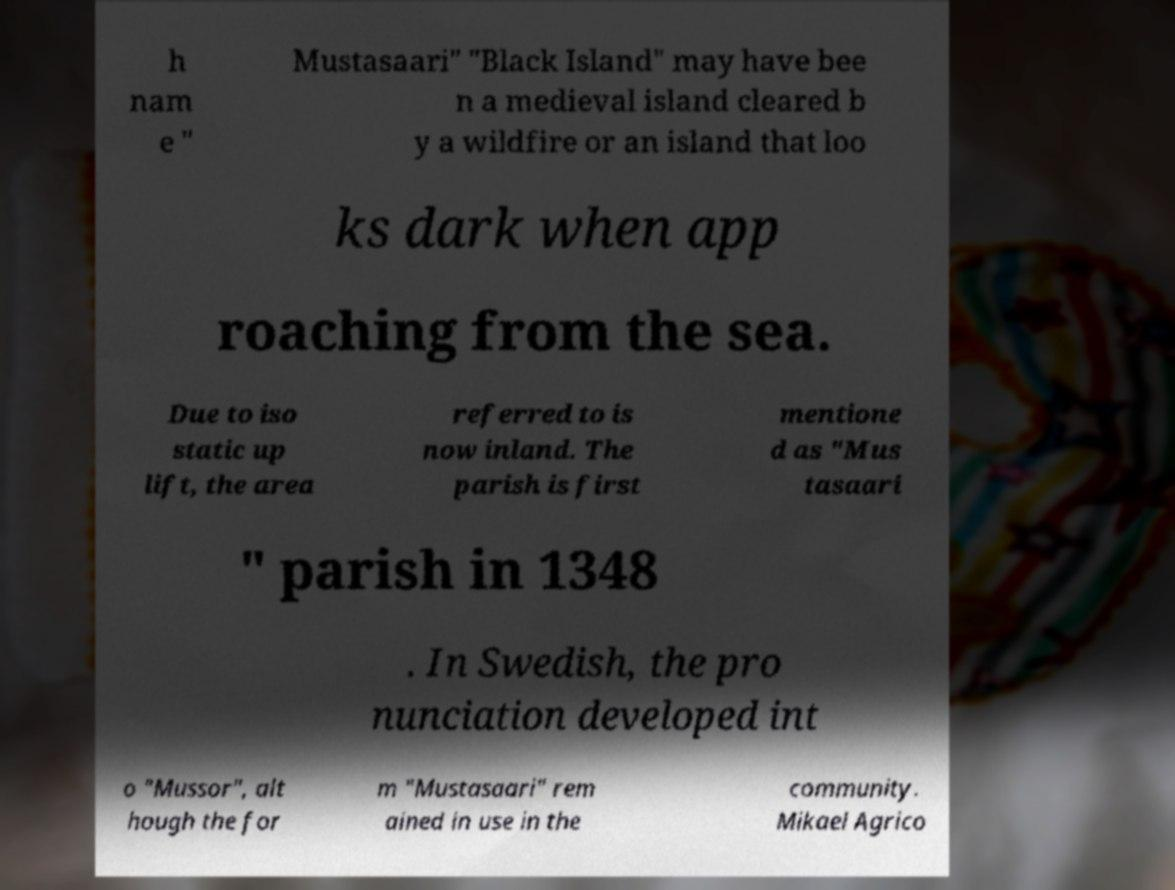For documentation purposes, I need the text within this image transcribed. Could you provide that? h nam e " Mustasaari" "Black Island" may have bee n a medieval island cleared b y a wildfire or an island that loo ks dark when app roaching from the sea. Due to iso static up lift, the area referred to is now inland. The parish is first mentione d as "Mus tasaari " parish in 1348 . In Swedish, the pro nunciation developed int o "Mussor", alt hough the for m "Mustasaari" rem ained in use in the community. Mikael Agrico 